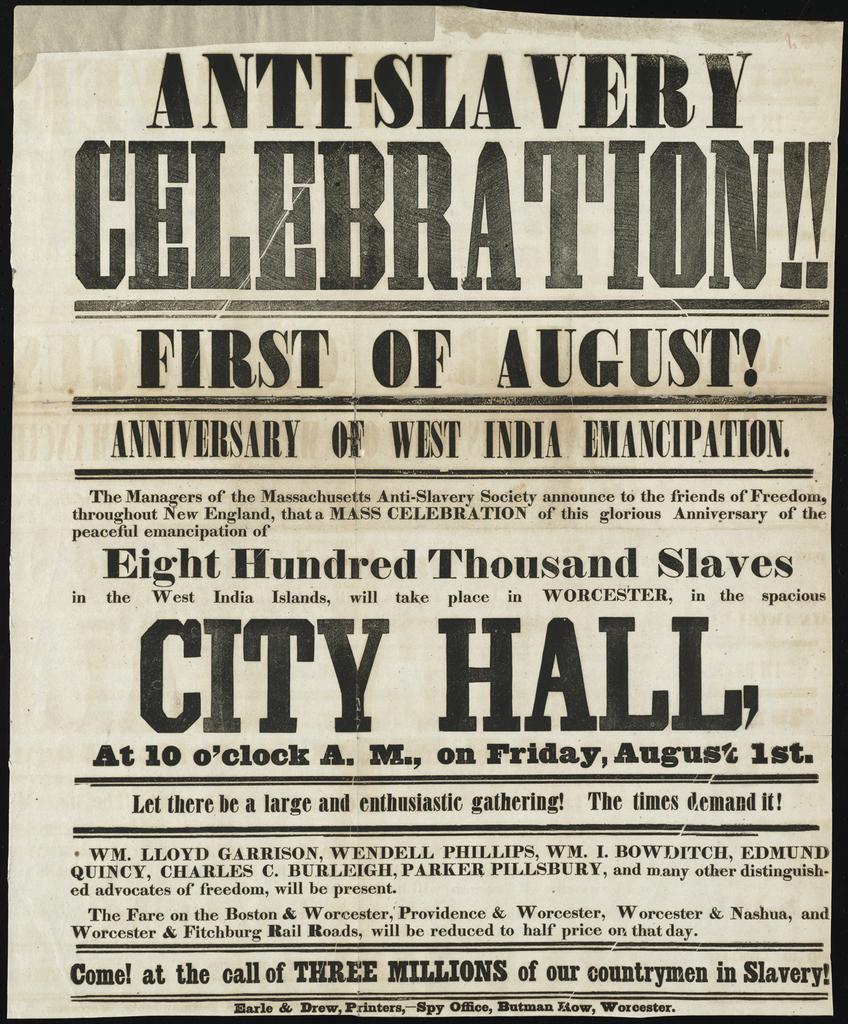Is this flyer in bold print?
Keep it short and to the point. Yes. 